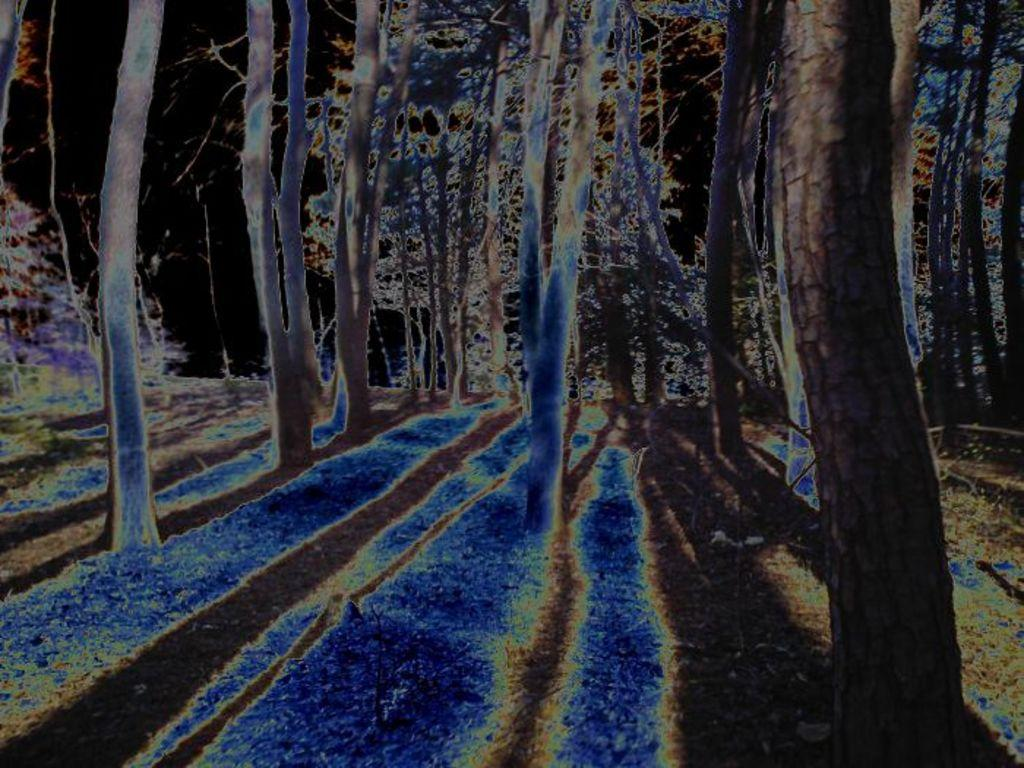What type of vegetation can be seen in the image? There are trees in the image. What color is the background of the image? The background of the image is black. What colors are present in the image besides the black background? Blue and brown colors are present in the image. What country is depicted in the image? There is no country depicted in the image; it only features trees and a black background. Does the existence of trees in the image prove the existence of a parallel universe? The presence of trees in the image does not prove the existence of a parallel universe, as the image only shows trees and a black background. 